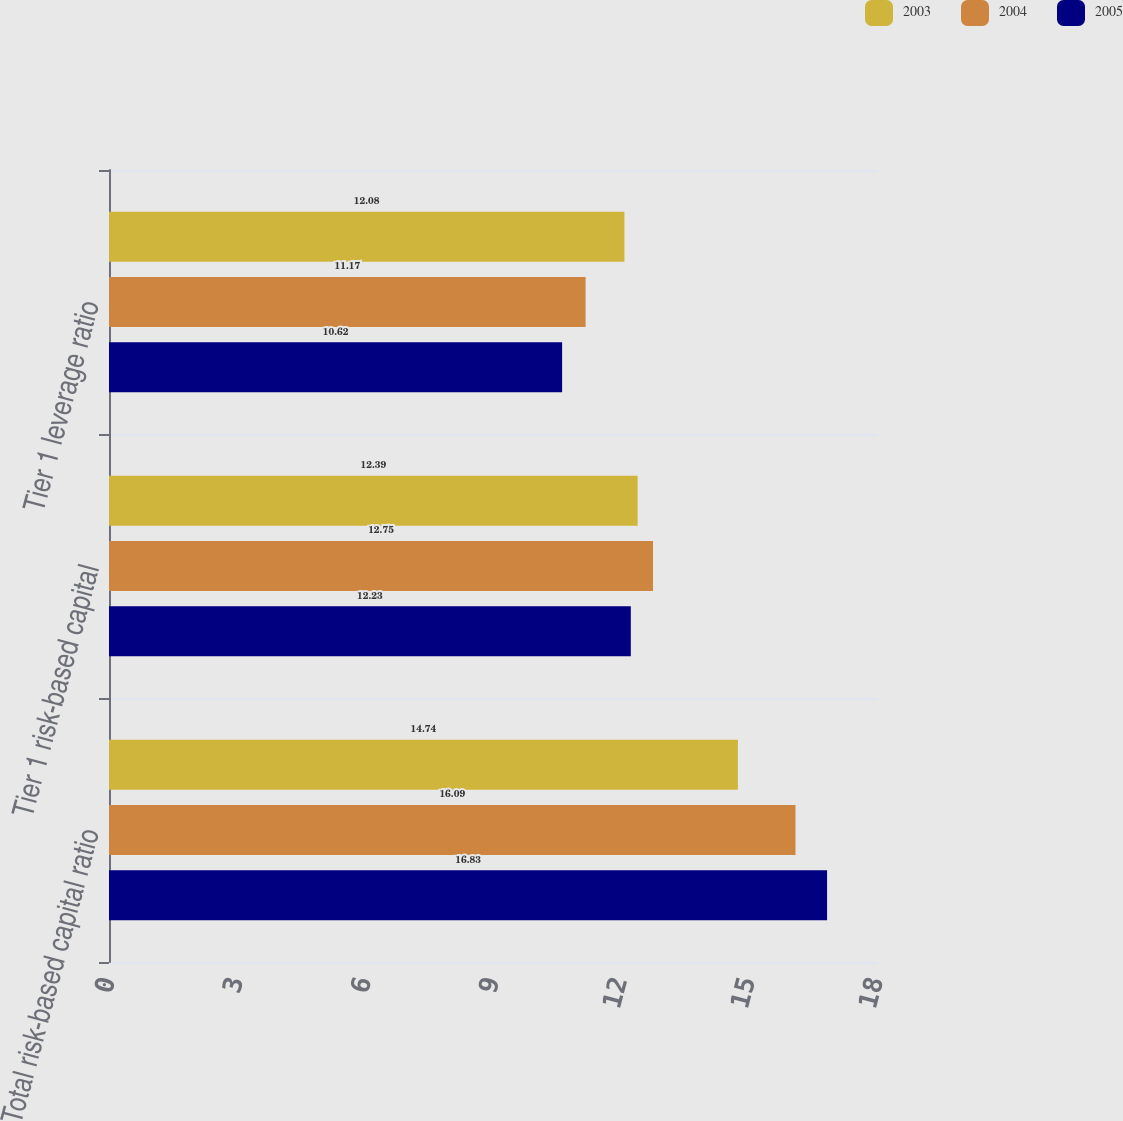<chart> <loc_0><loc_0><loc_500><loc_500><stacked_bar_chart><ecel><fcel>Total risk-based capital ratio<fcel>Tier 1 risk-based capital<fcel>Tier 1 leverage ratio<nl><fcel>2003<fcel>14.74<fcel>12.39<fcel>12.08<nl><fcel>2004<fcel>16.09<fcel>12.75<fcel>11.17<nl><fcel>2005<fcel>16.83<fcel>12.23<fcel>10.62<nl></chart> 